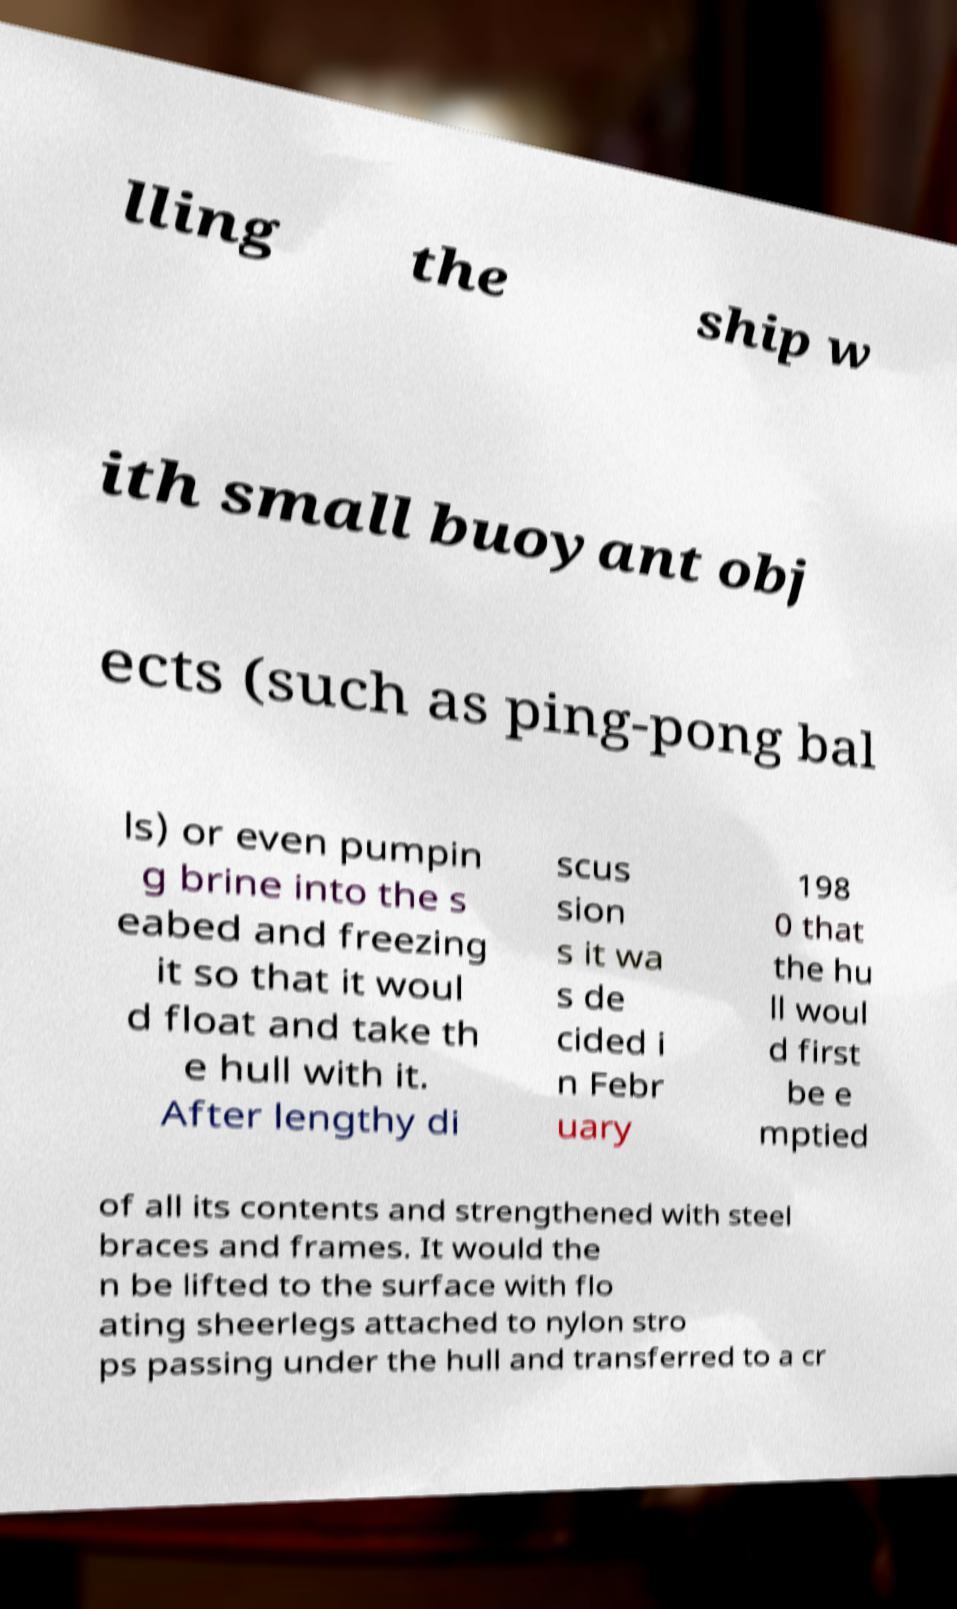Can you accurately transcribe the text from the provided image for me? lling the ship w ith small buoyant obj ects (such as ping-pong bal ls) or even pumpin g brine into the s eabed and freezing it so that it woul d float and take th e hull with it. After lengthy di scus sion s it wa s de cided i n Febr uary 198 0 that the hu ll woul d first be e mptied of all its contents and strengthened with steel braces and frames. It would the n be lifted to the surface with flo ating sheerlegs attached to nylon stro ps passing under the hull and transferred to a cr 